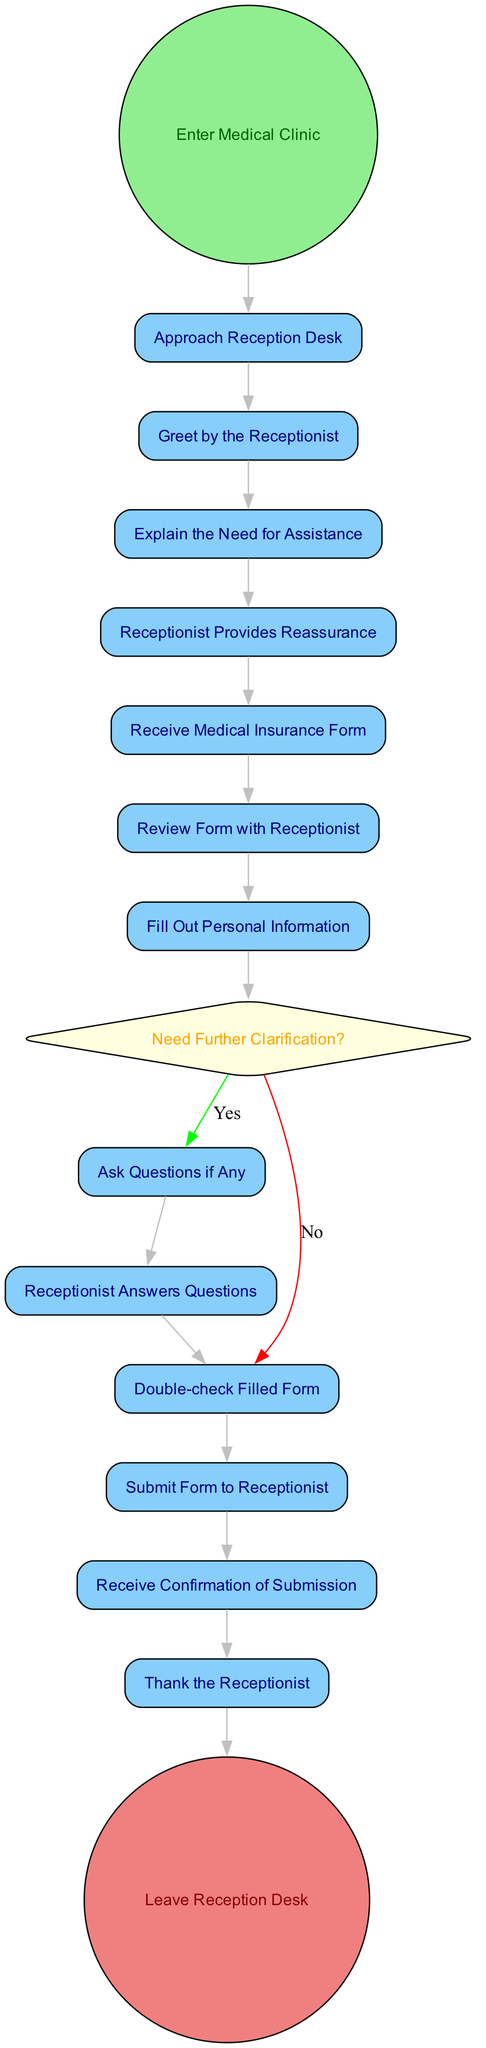What is the starting activity in the diagram? The diagram begins with the "Enter Medical Clinic" activity, which is marked as the starting point. There is only one starting activity, and it is presented at the top of the flow.
Answer: Enter Medical Clinic How many action nodes are in the diagram? By counting the action nodes listed in the activities, there are eleven action nodes: from "Approach Reception Desk" to "Thank the Receptionist." Each is a discrete step in the process.
Answer: Eleven What is the last action before leaving the reception desk? The last action before leaving the reception desk is "Thank the Receptionist," which occurs just before the final action of leaving the desk.
Answer: Thank the Receptionist What happens if clarification is needed after filling out the personal information? When clarification is needed, the flow goes to "Ask Questions if Any," indicating that the patient can raise their queries. This stems from the decision point questioning whether further clarification is necessary.
Answer: Ask Questions if Any How many decision nodes are present in the diagram? There is only one decision node shown in the diagram, which pertains to whether further clarification is needed after filling out personal information.
Answer: One What is the relationship between "Receive Medical Insurance Form" and "Review Form with Receptionist"? The relationship is sequential: after receiving the medical insurance form, the next step is to "Review Form with Receptionist." This indicates a direct flow between these two activities.
Answer: Sequential relationship What are the options available at the decision node for further clarification? The options available at that decision node are "Yes" and "No," which determine the subsequent action based on the patient's need for clarification.
Answer: Yes, No When does the receptionist provide reassurance to the patient? The receptionist provides reassurance immediately after the patient explains their need for assistance, indicating a supportive interaction during the process.
Answer: After explaining need for assistance What activity follows the submission of the form to the receptionist? After the form is submitted to the receptionist, the next activity is "Receive Confirmation of Submission," which indicates that the patient has completed this portion of the process.
Answer: Receive Confirmation of Submission 